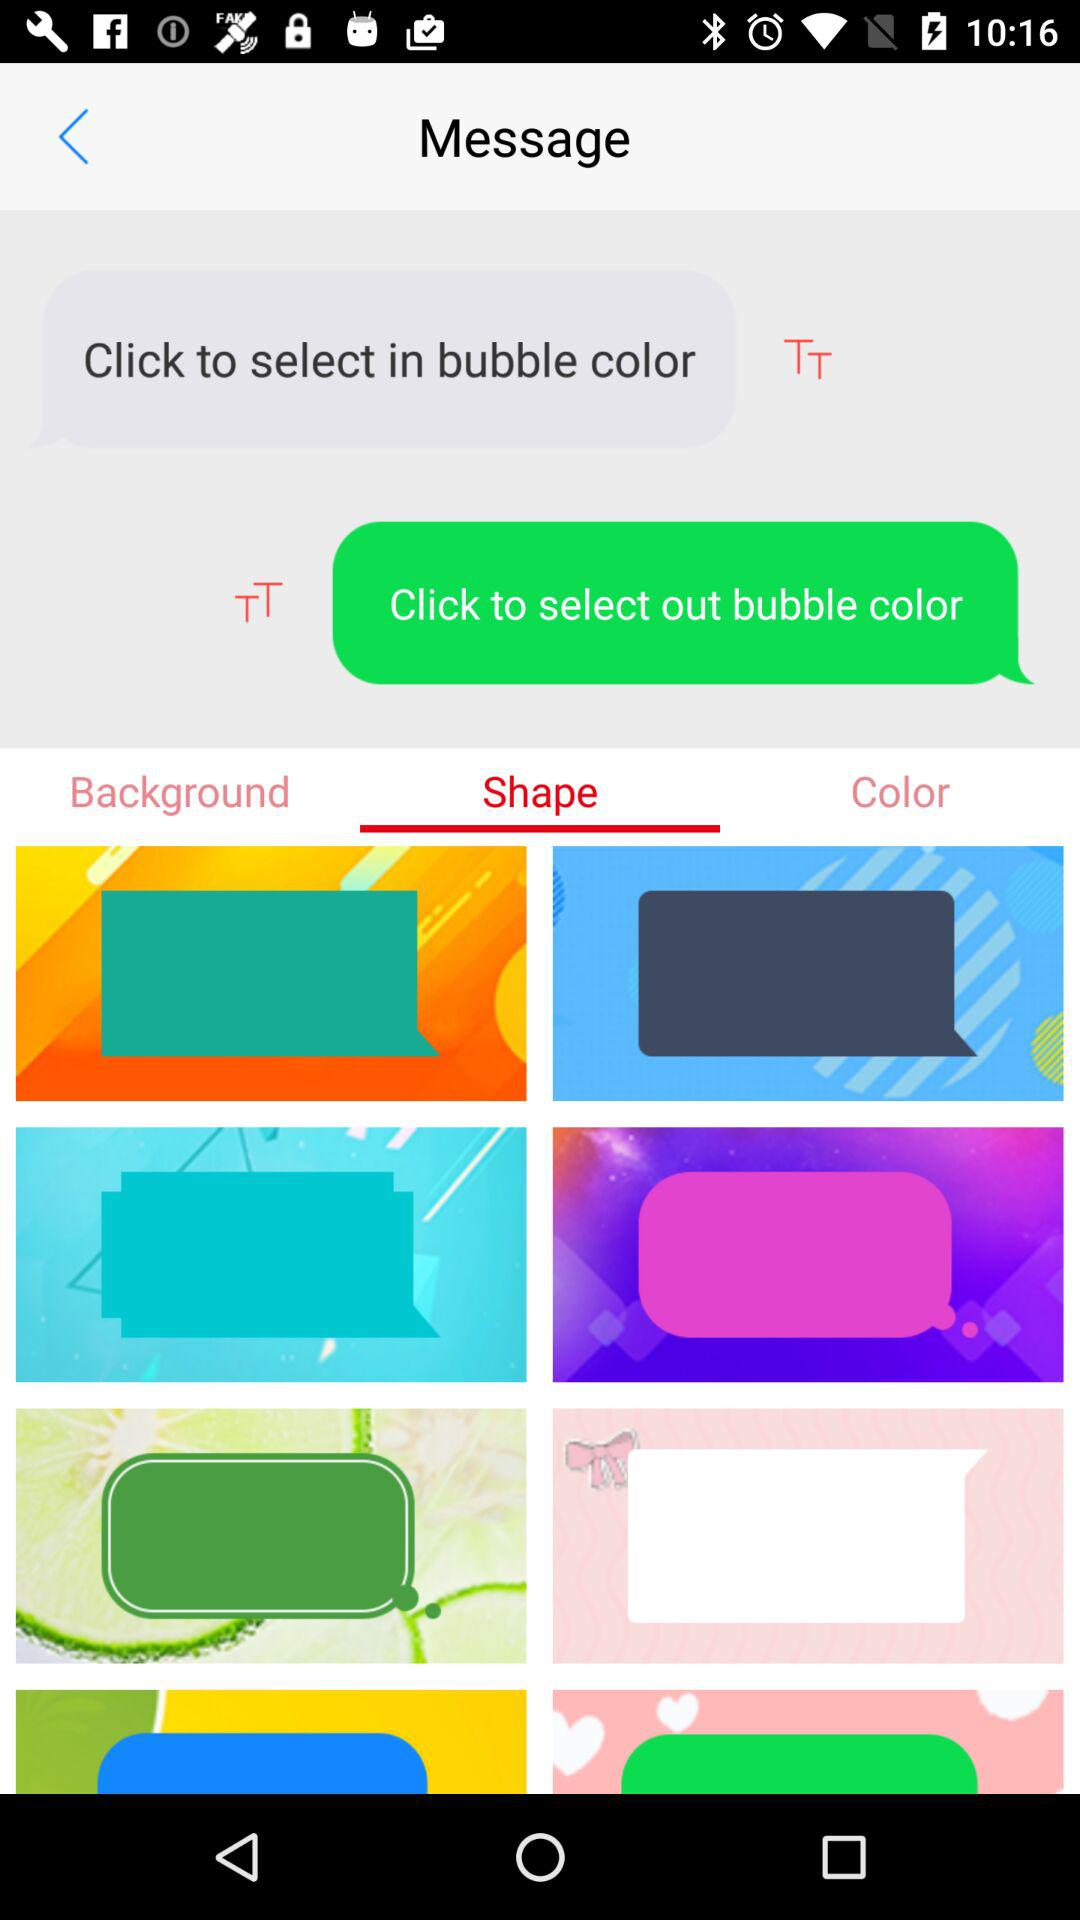How many items have a pink background?
Answer the question using a single word or phrase. 2 